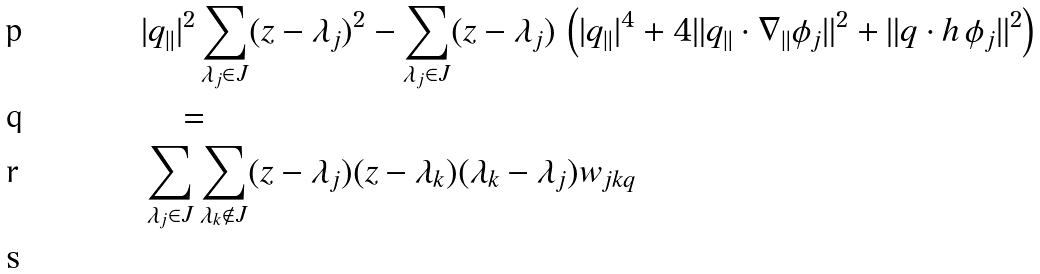Convert formula to latex. <formula><loc_0><loc_0><loc_500><loc_500>& | { q } _ { \| } | ^ { 2 } \sum _ { \lambda _ { j } \in J } ( z - \lambda _ { j } ) ^ { 2 } - \sum _ { \lambda _ { j } \in J } ( z - \lambda _ { j } ) \, \left ( | { q } _ { \| } | ^ { 4 } + 4 \| { q } _ { \| } \cdot \nabla _ { \| } \phi _ { j } \| ^ { 2 } + \| { q } \cdot { h } \, \phi _ { j } \| ^ { 2 } \right ) \\ & \quad = \\ & \sum _ { \lambda _ { j } \in J } \sum _ { \lambda _ { k } \notin J } ( z - \lambda _ { j } ) ( z - \lambda _ { k } ) ( \lambda _ { k } - \lambda _ { j } ) w _ { j k { q } } \\</formula> 